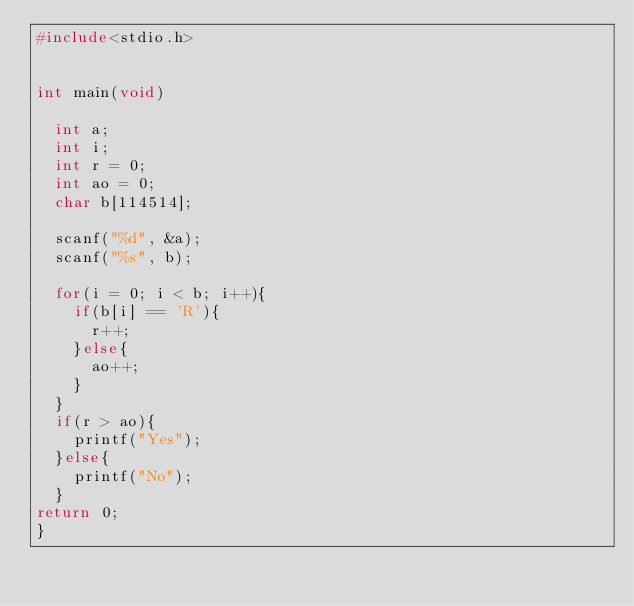Convert code to text. <code><loc_0><loc_0><loc_500><loc_500><_C_>#include<stdio.h>


int main(void)
  
  int a;
  int i;
  int r = 0;
  int ao = 0;
  char b[114514];

  scanf("%d", &a);
  scanf("%s", b);

  for(i = 0; i < b; i++){
    if(b[i] == 'R'){
      r++;
    }else{
      ao++;
    }
  }
  if(r > ao){
    printf("Yes");
  }else{
    printf("No");
  }
return 0;
}
    </code> 